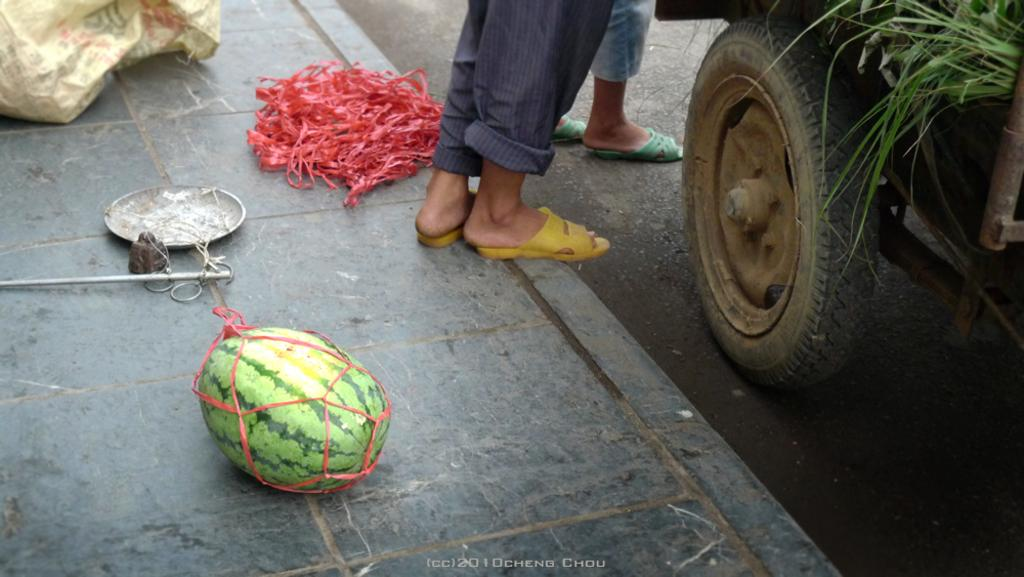What can be seen on the ground in the image? There are human legs on the ground in the image. What is located in the background of the image? There is a motor vehicle, grass, a watermelon, a simple balance, and a polythene bag in the background of the image. What type of lettuce is being cooked in the image? There is no lettuce or cooking activity present in the image. 